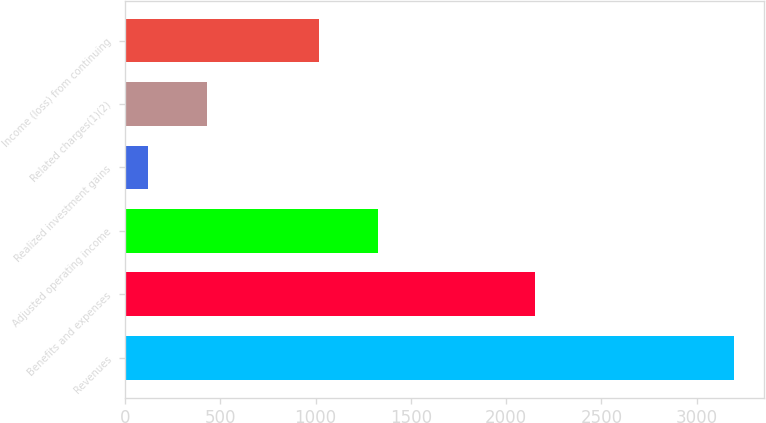Convert chart to OTSL. <chart><loc_0><loc_0><loc_500><loc_500><bar_chart><fcel>Revenues<fcel>Benefits and expenses<fcel>Adjusted operating income<fcel>Realized investment gains<fcel>Related charges(1)(2)<fcel>Income (loss) from continuing<nl><fcel>3195<fcel>2149<fcel>1326.5<fcel>120<fcel>427.5<fcel>1019<nl></chart> 